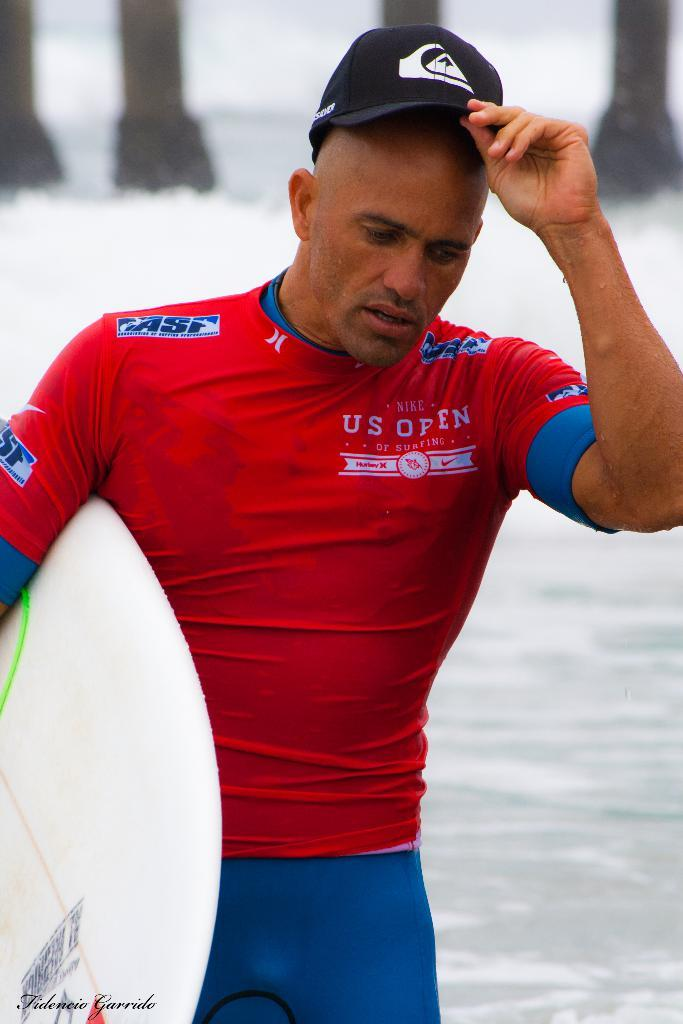<image>
Create a compact narrative representing the image presented. A man in a red shirt saying US Open 